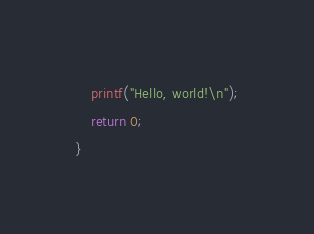<code> <loc_0><loc_0><loc_500><loc_500><_C_>    printf("Hello, world!\n");
    return 0;
}</code> 